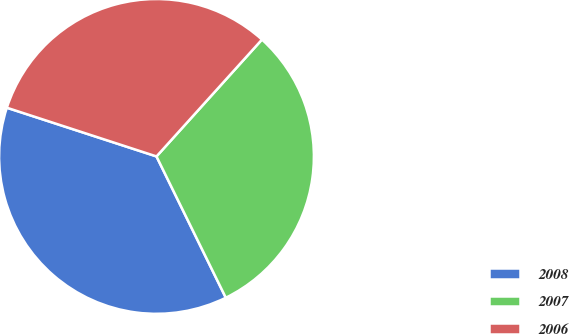Convert chart. <chart><loc_0><loc_0><loc_500><loc_500><pie_chart><fcel>2008<fcel>2007<fcel>2006<nl><fcel>37.27%<fcel>31.06%<fcel>31.68%<nl></chart> 